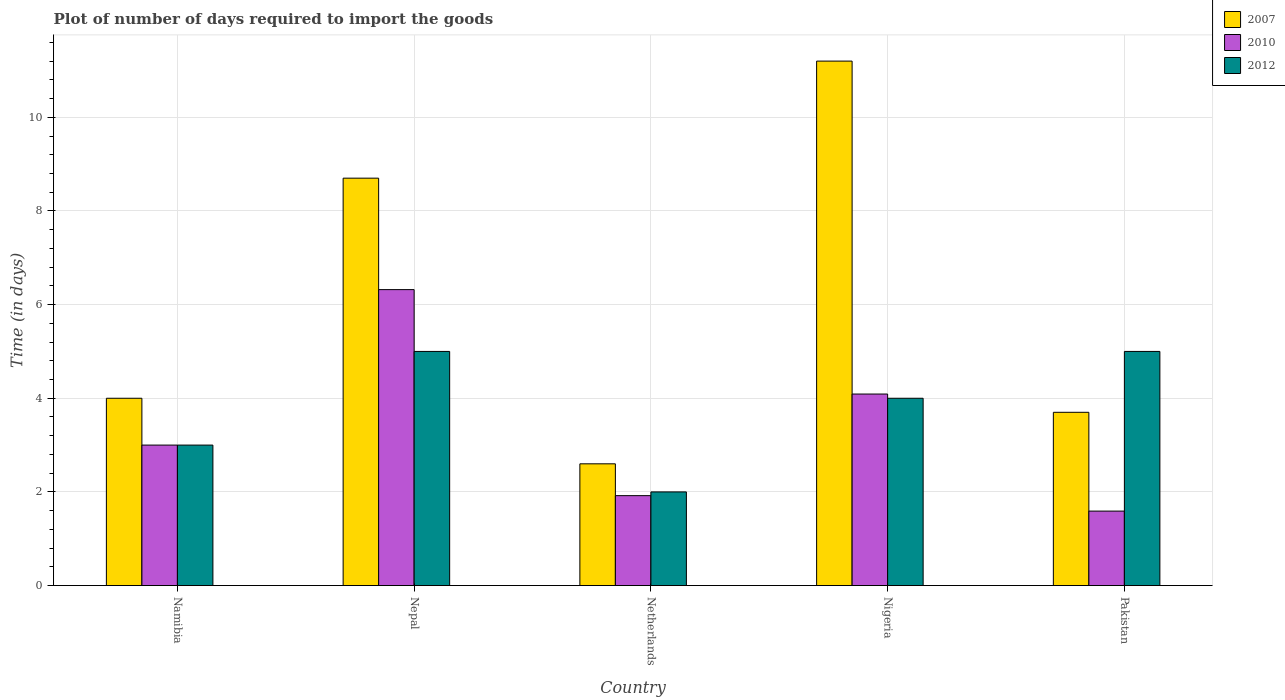How many groups of bars are there?
Ensure brevity in your answer.  5. How many bars are there on the 4th tick from the left?
Give a very brief answer. 3. How many bars are there on the 3rd tick from the right?
Make the answer very short. 3. What is the label of the 4th group of bars from the left?
Give a very brief answer. Nigeria. Across all countries, what is the maximum time required to import goods in 2007?
Provide a short and direct response. 11.2. In which country was the time required to import goods in 2010 maximum?
Give a very brief answer. Nepal. What is the total time required to import goods in 2010 in the graph?
Provide a succinct answer. 16.92. What is the difference between the time required to import goods in 2007 in Nepal and that in Nigeria?
Offer a very short reply. -2.5. What is the difference between the time required to import goods in 2007 in Nigeria and the time required to import goods in 2010 in Pakistan?
Ensure brevity in your answer.  9.61. What is the average time required to import goods in 2007 per country?
Your answer should be compact. 6.04. What is the difference between the time required to import goods of/in 2010 and time required to import goods of/in 2012 in Pakistan?
Your answer should be very brief. -3.41. What is the ratio of the time required to import goods in 2007 in Nigeria to that in Pakistan?
Offer a very short reply. 3.03. Is the time required to import goods in 2010 in Nepal less than that in Nigeria?
Your answer should be very brief. No. What is the difference between the highest and the second highest time required to import goods in 2012?
Your answer should be very brief. -1. What is the difference between the highest and the lowest time required to import goods in 2007?
Provide a succinct answer. 8.6. Is the sum of the time required to import goods in 2010 in Nepal and Nigeria greater than the maximum time required to import goods in 2007 across all countries?
Offer a very short reply. No. What does the 2nd bar from the left in Netherlands represents?
Your answer should be compact. 2010. How many bars are there?
Provide a short and direct response. 15. How many countries are there in the graph?
Your answer should be compact. 5. What is the difference between two consecutive major ticks on the Y-axis?
Your answer should be compact. 2. How many legend labels are there?
Offer a terse response. 3. How are the legend labels stacked?
Your answer should be very brief. Vertical. What is the title of the graph?
Offer a terse response. Plot of number of days required to import the goods. Does "1998" appear as one of the legend labels in the graph?
Offer a terse response. No. What is the label or title of the X-axis?
Ensure brevity in your answer.  Country. What is the label or title of the Y-axis?
Your answer should be compact. Time (in days). What is the Time (in days) of 2007 in Namibia?
Provide a short and direct response. 4. What is the Time (in days) of 2010 in Namibia?
Make the answer very short. 3. What is the Time (in days) in 2007 in Nepal?
Offer a very short reply. 8.7. What is the Time (in days) of 2010 in Nepal?
Ensure brevity in your answer.  6.32. What is the Time (in days) of 2012 in Nepal?
Give a very brief answer. 5. What is the Time (in days) of 2007 in Netherlands?
Your answer should be very brief. 2.6. What is the Time (in days) in 2010 in Netherlands?
Provide a succinct answer. 1.92. What is the Time (in days) in 2010 in Nigeria?
Your answer should be compact. 4.09. What is the Time (in days) in 2012 in Nigeria?
Your answer should be compact. 4. What is the Time (in days) in 2010 in Pakistan?
Give a very brief answer. 1.59. What is the Time (in days) of 2012 in Pakistan?
Provide a short and direct response. 5. Across all countries, what is the maximum Time (in days) in 2007?
Your answer should be compact. 11.2. Across all countries, what is the maximum Time (in days) of 2010?
Your answer should be very brief. 6.32. Across all countries, what is the maximum Time (in days) in 2012?
Provide a short and direct response. 5. Across all countries, what is the minimum Time (in days) in 2007?
Your response must be concise. 2.6. Across all countries, what is the minimum Time (in days) of 2010?
Your answer should be compact. 1.59. Across all countries, what is the minimum Time (in days) of 2012?
Offer a very short reply. 2. What is the total Time (in days) of 2007 in the graph?
Provide a short and direct response. 30.2. What is the total Time (in days) of 2010 in the graph?
Your answer should be very brief. 16.92. What is the total Time (in days) in 2012 in the graph?
Offer a terse response. 19. What is the difference between the Time (in days) in 2007 in Namibia and that in Nepal?
Your answer should be very brief. -4.7. What is the difference between the Time (in days) in 2010 in Namibia and that in Nepal?
Offer a terse response. -3.32. What is the difference between the Time (in days) of 2012 in Namibia and that in Nepal?
Ensure brevity in your answer.  -2. What is the difference between the Time (in days) in 2012 in Namibia and that in Netherlands?
Your response must be concise. 1. What is the difference between the Time (in days) of 2007 in Namibia and that in Nigeria?
Provide a succinct answer. -7.2. What is the difference between the Time (in days) in 2010 in Namibia and that in Nigeria?
Make the answer very short. -1.09. What is the difference between the Time (in days) of 2007 in Namibia and that in Pakistan?
Ensure brevity in your answer.  0.3. What is the difference between the Time (in days) in 2010 in Namibia and that in Pakistan?
Ensure brevity in your answer.  1.41. What is the difference between the Time (in days) in 2007 in Nepal and that in Netherlands?
Your answer should be compact. 6.1. What is the difference between the Time (in days) of 2010 in Nepal and that in Netherlands?
Offer a terse response. 4.4. What is the difference between the Time (in days) in 2012 in Nepal and that in Netherlands?
Offer a very short reply. 3. What is the difference between the Time (in days) of 2010 in Nepal and that in Nigeria?
Provide a short and direct response. 2.23. What is the difference between the Time (in days) in 2012 in Nepal and that in Nigeria?
Offer a terse response. 1. What is the difference between the Time (in days) in 2007 in Nepal and that in Pakistan?
Provide a short and direct response. 5. What is the difference between the Time (in days) in 2010 in Nepal and that in Pakistan?
Provide a succinct answer. 4.73. What is the difference between the Time (in days) of 2007 in Netherlands and that in Nigeria?
Provide a short and direct response. -8.6. What is the difference between the Time (in days) of 2010 in Netherlands and that in Nigeria?
Give a very brief answer. -2.17. What is the difference between the Time (in days) of 2010 in Netherlands and that in Pakistan?
Keep it short and to the point. 0.33. What is the difference between the Time (in days) in 2012 in Netherlands and that in Pakistan?
Give a very brief answer. -3. What is the difference between the Time (in days) of 2010 in Nigeria and that in Pakistan?
Keep it short and to the point. 2.5. What is the difference between the Time (in days) of 2007 in Namibia and the Time (in days) of 2010 in Nepal?
Your response must be concise. -2.32. What is the difference between the Time (in days) in 2007 in Namibia and the Time (in days) in 2010 in Netherlands?
Keep it short and to the point. 2.08. What is the difference between the Time (in days) in 2007 in Namibia and the Time (in days) in 2012 in Netherlands?
Your answer should be very brief. 2. What is the difference between the Time (in days) in 2010 in Namibia and the Time (in days) in 2012 in Netherlands?
Ensure brevity in your answer.  1. What is the difference between the Time (in days) of 2007 in Namibia and the Time (in days) of 2010 in Nigeria?
Provide a succinct answer. -0.09. What is the difference between the Time (in days) of 2007 in Namibia and the Time (in days) of 2010 in Pakistan?
Your response must be concise. 2.41. What is the difference between the Time (in days) of 2010 in Namibia and the Time (in days) of 2012 in Pakistan?
Your response must be concise. -2. What is the difference between the Time (in days) of 2007 in Nepal and the Time (in days) of 2010 in Netherlands?
Keep it short and to the point. 6.78. What is the difference between the Time (in days) of 2010 in Nepal and the Time (in days) of 2012 in Netherlands?
Your answer should be compact. 4.32. What is the difference between the Time (in days) in 2007 in Nepal and the Time (in days) in 2010 in Nigeria?
Keep it short and to the point. 4.61. What is the difference between the Time (in days) of 2010 in Nepal and the Time (in days) of 2012 in Nigeria?
Keep it short and to the point. 2.32. What is the difference between the Time (in days) in 2007 in Nepal and the Time (in days) in 2010 in Pakistan?
Your answer should be very brief. 7.11. What is the difference between the Time (in days) in 2007 in Nepal and the Time (in days) in 2012 in Pakistan?
Make the answer very short. 3.7. What is the difference between the Time (in days) of 2010 in Nepal and the Time (in days) of 2012 in Pakistan?
Make the answer very short. 1.32. What is the difference between the Time (in days) of 2007 in Netherlands and the Time (in days) of 2010 in Nigeria?
Give a very brief answer. -1.49. What is the difference between the Time (in days) in 2007 in Netherlands and the Time (in days) in 2012 in Nigeria?
Your response must be concise. -1.4. What is the difference between the Time (in days) in 2010 in Netherlands and the Time (in days) in 2012 in Nigeria?
Give a very brief answer. -2.08. What is the difference between the Time (in days) in 2010 in Netherlands and the Time (in days) in 2012 in Pakistan?
Make the answer very short. -3.08. What is the difference between the Time (in days) of 2007 in Nigeria and the Time (in days) of 2010 in Pakistan?
Keep it short and to the point. 9.61. What is the difference between the Time (in days) in 2010 in Nigeria and the Time (in days) in 2012 in Pakistan?
Your answer should be compact. -0.91. What is the average Time (in days) in 2007 per country?
Your answer should be compact. 6.04. What is the average Time (in days) of 2010 per country?
Offer a very short reply. 3.38. What is the average Time (in days) of 2012 per country?
Keep it short and to the point. 3.8. What is the difference between the Time (in days) of 2007 and Time (in days) of 2012 in Namibia?
Provide a short and direct response. 1. What is the difference between the Time (in days) of 2007 and Time (in days) of 2010 in Nepal?
Ensure brevity in your answer.  2.38. What is the difference between the Time (in days) of 2010 and Time (in days) of 2012 in Nepal?
Offer a very short reply. 1.32. What is the difference between the Time (in days) in 2007 and Time (in days) in 2010 in Netherlands?
Give a very brief answer. 0.68. What is the difference between the Time (in days) in 2010 and Time (in days) in 2012 in Netherlands?
Your response must be concise. -0.08. What is the difference between the Time (in days) in 2007 and Time (in days) in 2010 in Nigeria?
Make the answer very short. 7.11. What is the difference between the Time (in days) in 2010 and Time (in days) in 2012 in Nigeria?
Offer a very short reply. 0.09. What is the difference between the Time (in days) of 2007 and Time (in days) of 2010 in Pakistan?
Make the answer very short. 2.11. What is the difference between the Time (in days) of 2007 and Time (in days) of 2012 in Pakistan?
Your answer should be compact. -1.3. What is the difference between the Time (in days) of 2010 and Time (in days) of 2012 in Pakistan?
Offer a very short reply. -3.41. What is the ratio of the Time (in days) of 2007 in Namibia to that in Nepal?
Give a very brief answer. 0.46. What is the ratio of the Time (in days) of 2010 in Namibia to that in Nepal?
Give a very brief answer. 0.47. What is the ratio of the Time (in days) in 2012 in Namibia to that in Nepal?
Make the answer very short. 0.6. What is the ratio of the Time (in days) in 2007 in Namibia to that in Netherlands?
Make the answer very short. 1.54. What is the ratio of the Time (in days) in 2010 in Namibia to that in Netherlands?
Your answer should be very brief. 1.56. What is the ratio of the Time (in days) in 2007 in Namibia to that in Nigeria?
Your answer should be very brief. 0.36. What is the ratio of the Time (in days) in 2010 in Namibia to that in Nigeria?
Provide a short and direct response. 0.73. What is the ratio of the Time (in days) in 2007 in Namibia to that in Pakistan?
Your answer should be very brief. 1.08. What is the ratio of the Time (in days) in 2010 in Namibia to that in Pakistan?
Your answer should be very brief. 1.89. What is the ratio of the Time (in days) of 2007 in Nepal to that in Netherlands?
Keep it short and to the point. 3.35. What is the ratio of the Time (in days) in 2010 in Nepal to that in Netherlands?
Your answer should be very brief. 3.29. What is the ratio of the Time (in days) of 2012 in Nepal to that in Netherlands?
Offer a terse response. 2.5. What is the ratio of the Time (in days) in 2007 in Nepal to that in Nigeria?
Give a very brief answer. 0.78. What is the ratio of the Time (in days) of 2010 in Nepal to that in Nigeria?
Offer a terse response. 1.55. What is the ratio of the Time (in days) in 2007 in Nepal to that in Pakistan?
Provide a succinct answer. 2.35. What is the ratio of the Time (in days) of 2010 in Nepal to that in Pakistan?
Your response must be concise. 3.97. What is the ratio of the Time (in days) in 2007 in Netherlands to that in Nigeria?
Offer a very short reply. 0.23. What is the ratio of the Time (in days) in 2010 in Netherlands to that in Nigeria?
Make the answer very short. 0.47. What is the ratio of the Time (in days) of 2012 in Netherlands to that in Nigeria?
Provide a short and direct response. 0.5. What is the ratio of the Time (in days) of 2007 in Netherlands to that in Pakistan?
Give a very brief answer. 0.7. What is the ratio of the Time (in days) in 2010 in Netherlands to that in Pakistan?
Provide a succinct answer. 1.21. What is the ratio of the Time (in days) in 2007 in Nigeria to that in Pakistan?
Your response must be concise. 3.03. What is the ratio of the Time (in days) of 2010 in Nigeria to that in Pakistan?
Make the answer very short. 2.57. What is the ratio of the Time (in days) in 2012 in Nigeria to that in Pakistan?
Ensure brevity in your answer.  0.8. What is the difference between the highest and the second highest Time (in days) of 2010?
Your answer should be compact. 2.23. What is the difference between the highest and the second highest Time (in days) in 2012?
Give a very brief answer. 0. What is the difference between the highest and the lowest Time (in days) in 2010?
Your answer should be very brief. 4.73. What is the difference between the highest and the lowest Time (in days) in 2012?
Your answer should be very brief. 3. 